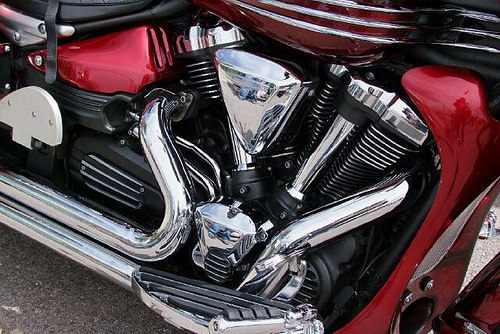<image>
Can you confirm if the concrete is in front of the foot rest? No. The concrete is not in front of the foot rest. The spatial positioning shows a different relationship between these objects. 